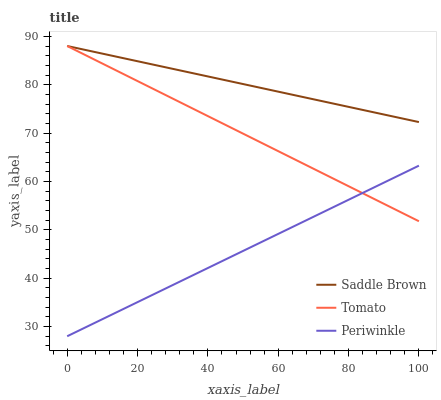Does Periwinkle have the minimum area under the curve?
Answer yes or no. Yes. Does Saddle Brown have the maximum area under the curve?
Answer yes or no. Yes. Does Saddle Brown have the minimum area under the curve?
Answer yes or no. No. Does Periwinkle have the maximum area under the curve?
Answer yes or no. No. Is Tomato the smoothest?
Answer yes or no. Yes. Is Saddle Brown the roughest?
Answer yes or no. Yes. Is Periwinkle the smoothest?
Answer yes or no. No. Is Periwinkle the roughest?
Answer yes or no. No. Does Saddle Brown have the lowest value?
Answer yes or no. No. Does Periwinkle have the highest value?
Answer yes or no. No. Is Periwinkle less than Saddle Brown?
Answer yes or no. Yes. Is Saddle Brown greater than Periwinkle?
Answer yes or no. Yes. Does Periwinkle intersect Saddle Brown?
Answer yes or no. No. 